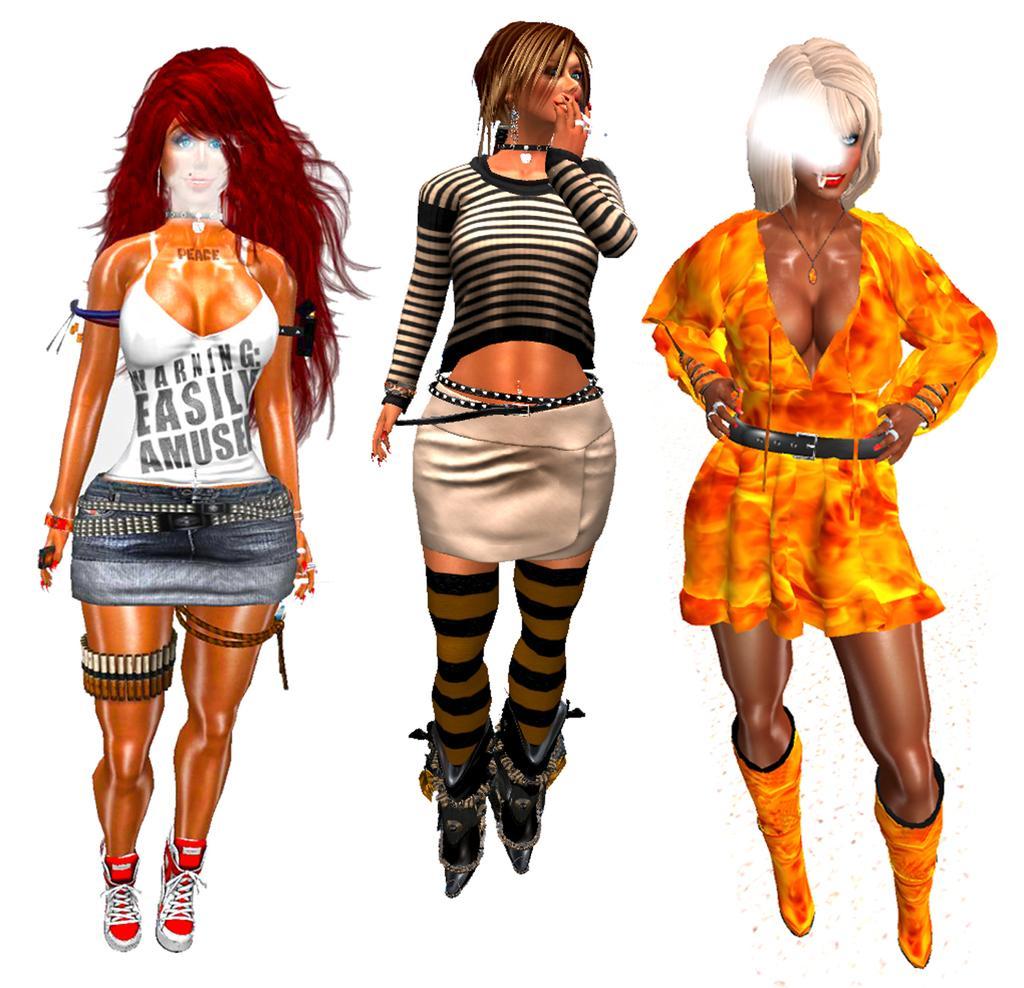In one or two sentences, can you explain what this image depicts? In this image I can see three animated people and wearing different color dress. Background is in white color. 